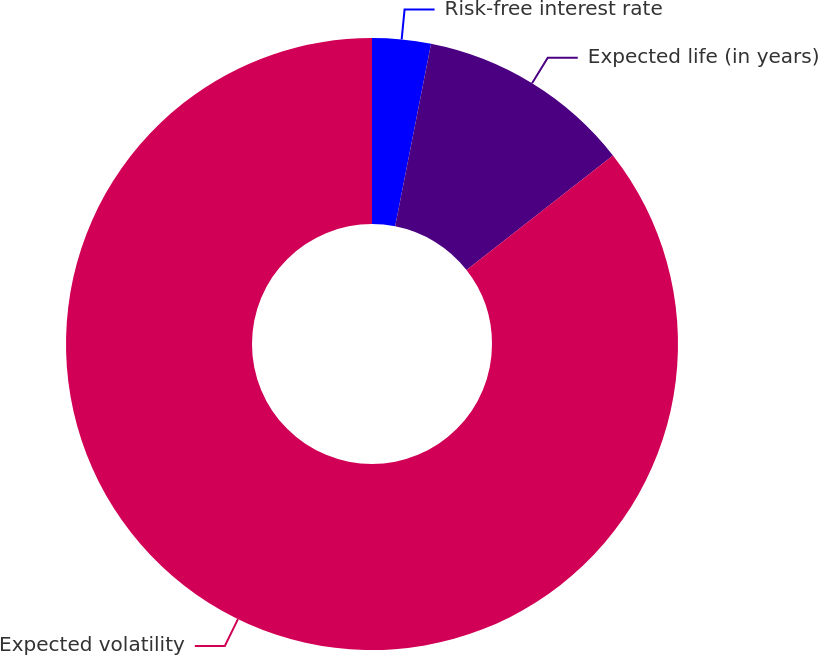Convert chart. <chart><loc_0><loc_0><loc_500><loc_500><pie_chart><fcel>Risk-free interest rate<fcel>Expected life (in years)<fcel>Expected volatility<nl><fcel>3.09%<fcel>11.34%<fcel>85.56%<nl></chart> 